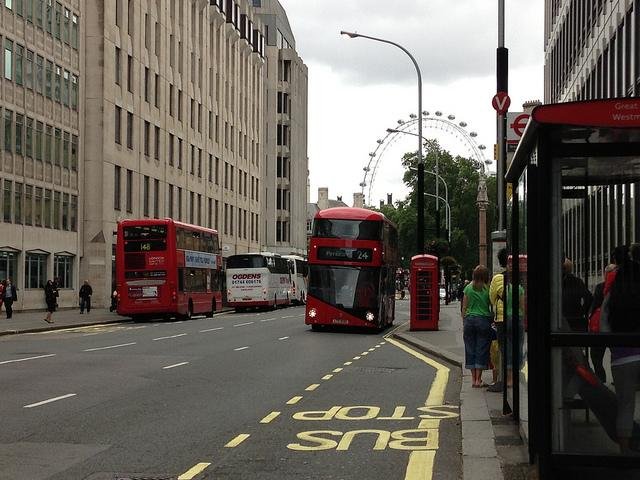What company owns vehicles similar to the ones in the street? greyhound 